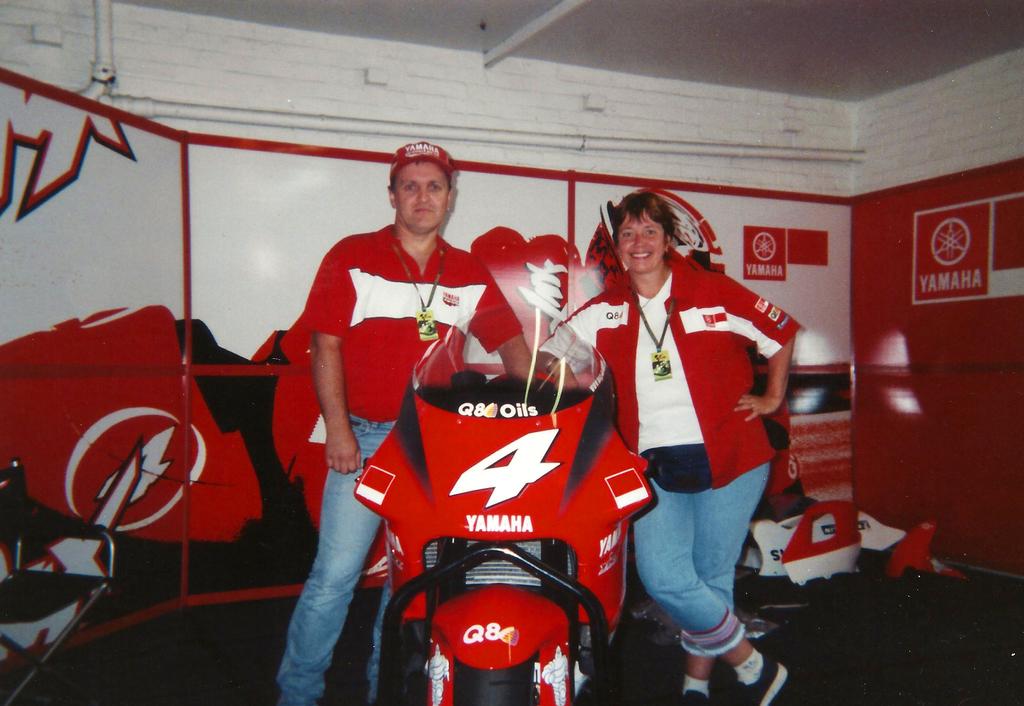What number is on the bike?
Give a very brief answer. 4. 